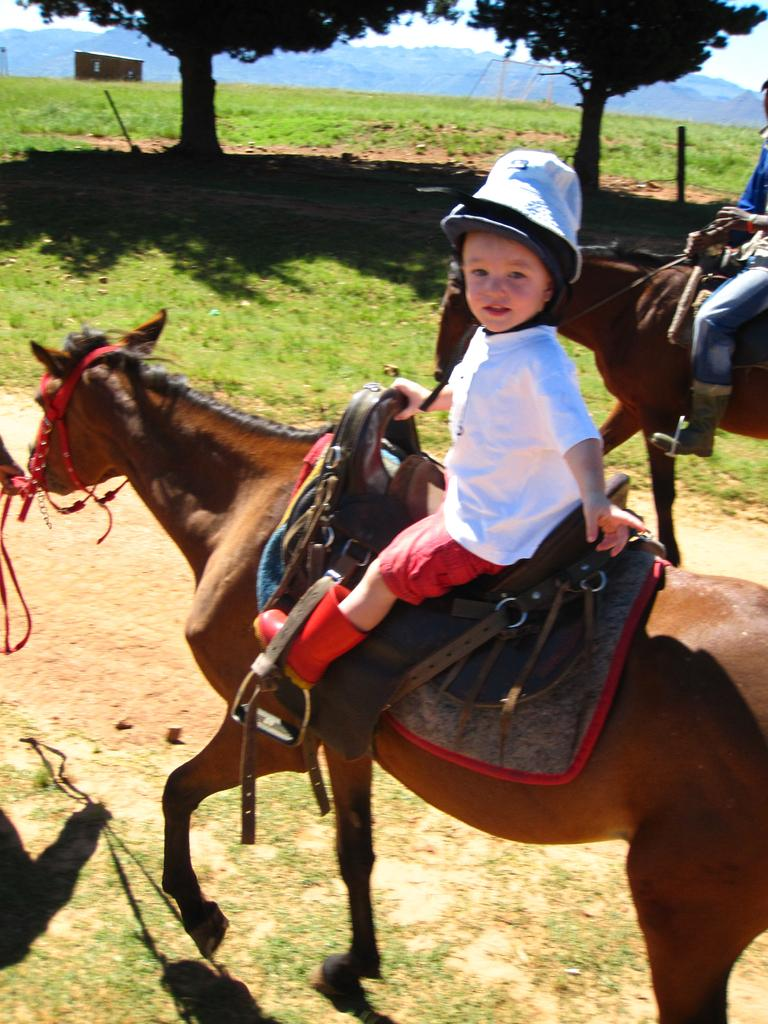How many people are in the image? There are two persons in the image. What are the persons doing in the image? The two persons are sitting on a horse. What are the persons wearing on their heads? The persons are wearing hats. What can be seen in the background of the image? There is a sky, a tree, grass, and a hill visible in the background of the image. What type of shoes are the persons wearing in the image? There is no information about shoes in the image, as the persons are sitting on a horse and their feet are not visible. 